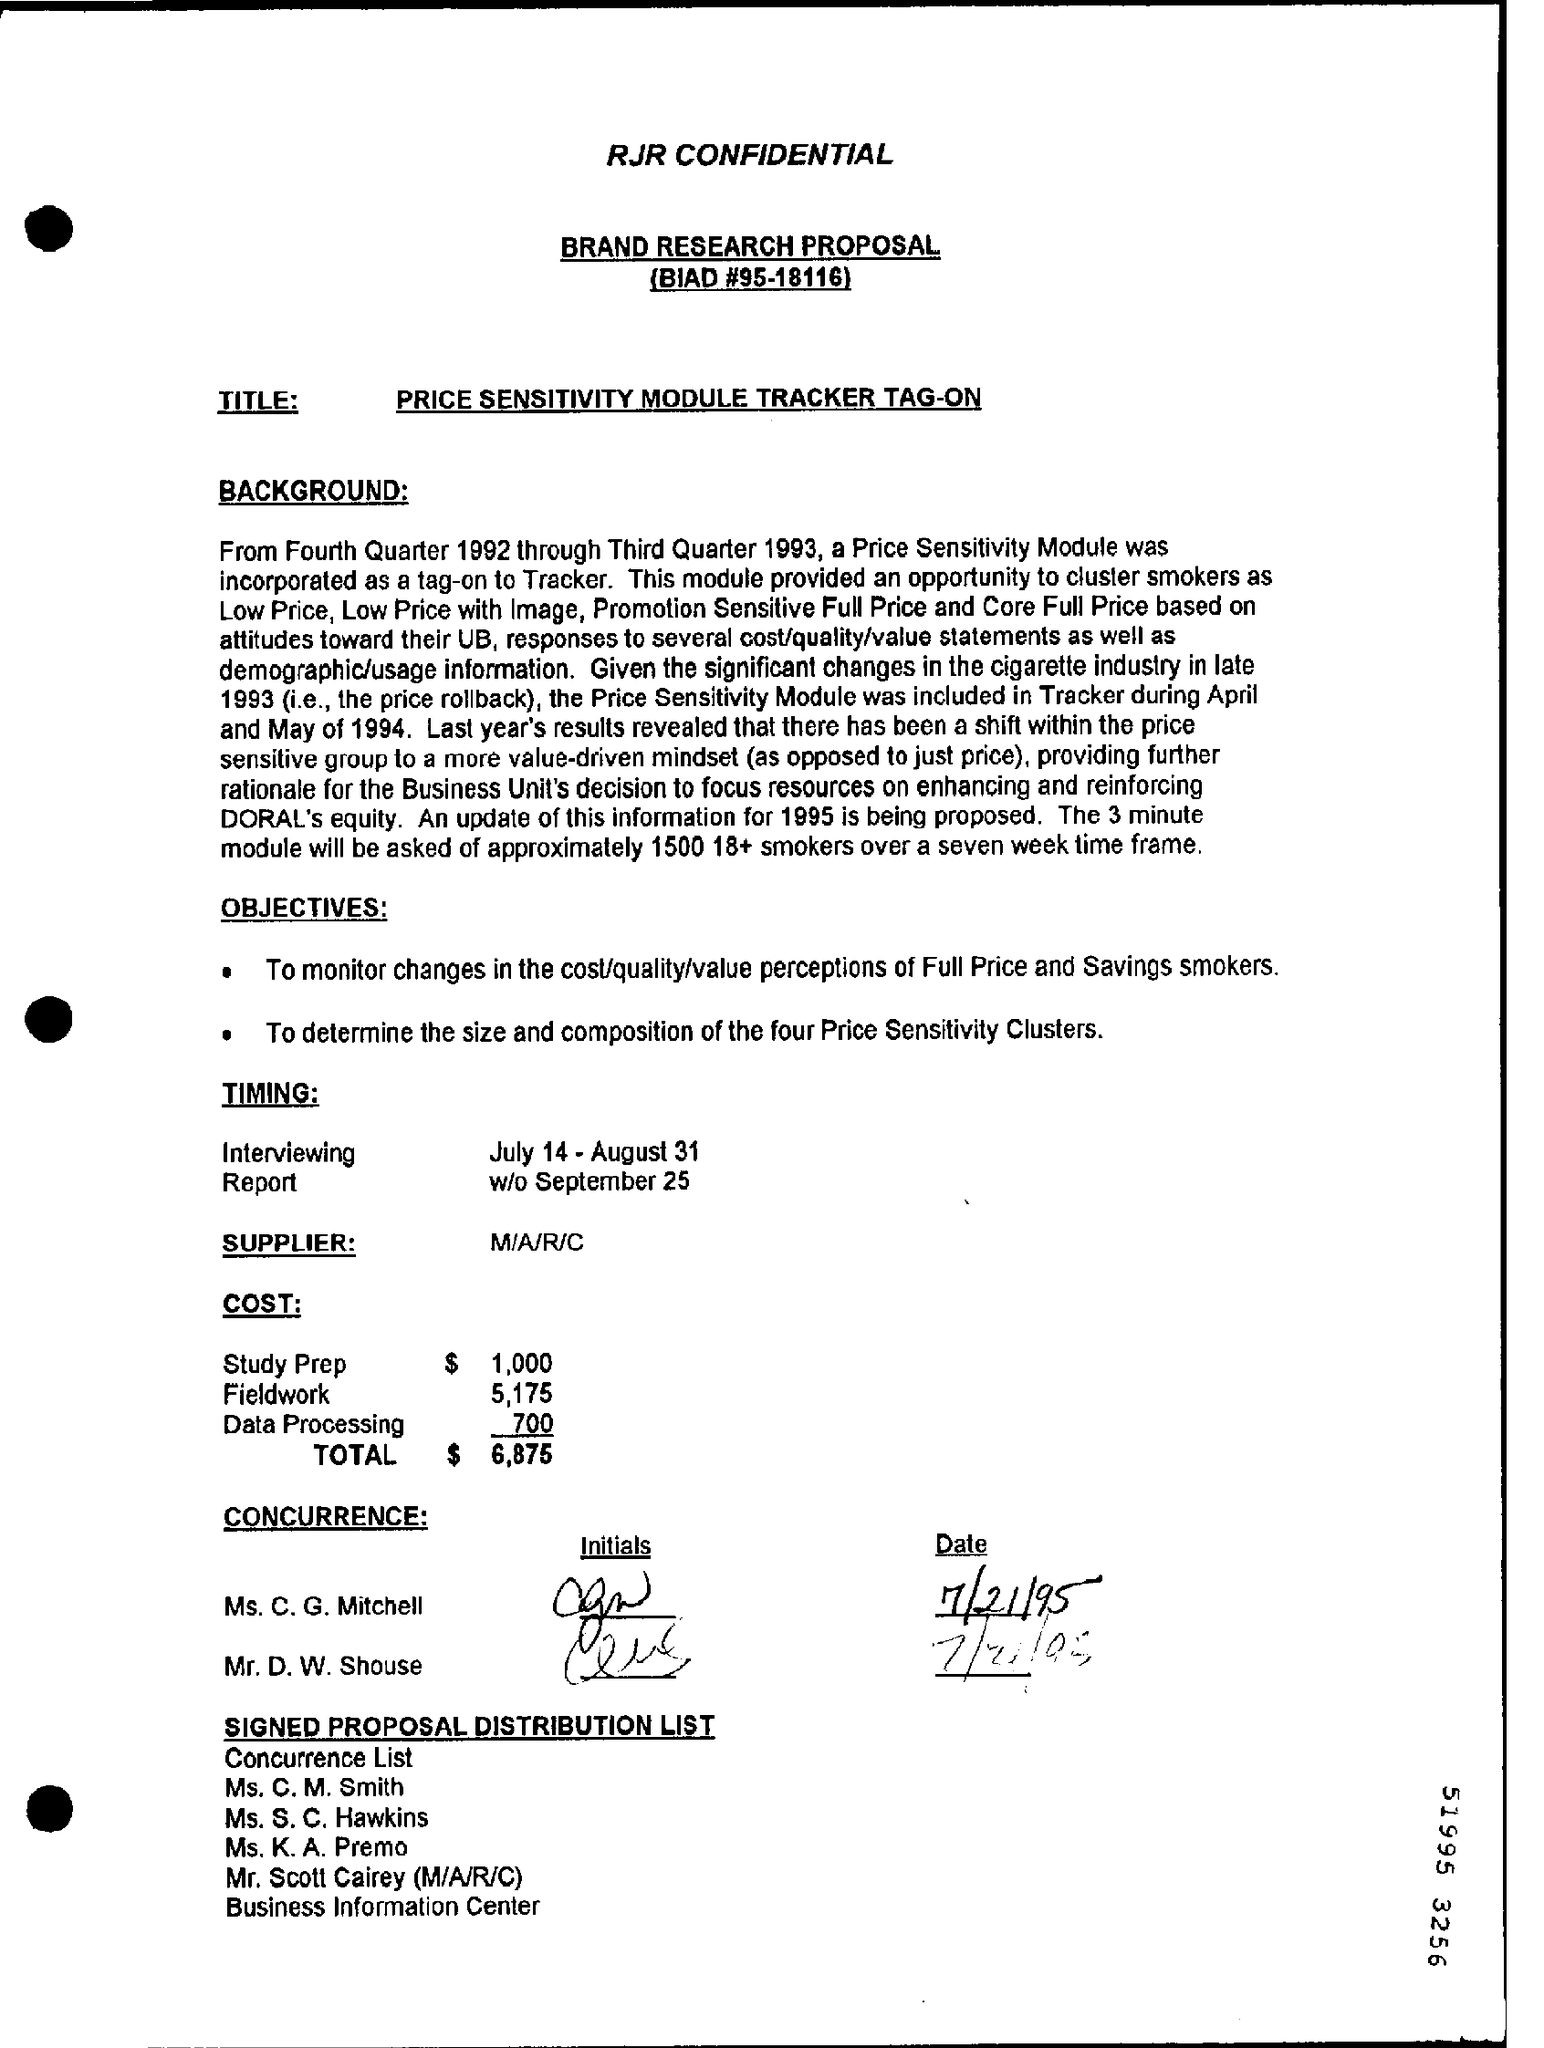Give some essential details in this illustration. What is the BIAD number? It is 95-18116. The total cost is $6,875 as mentioned. 